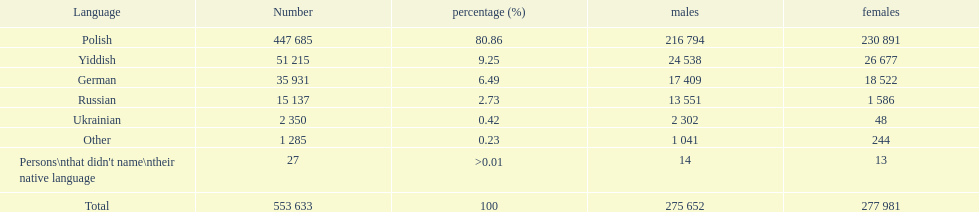What are the proportions of individuals? 80.86, 9.25, 6.49, 2.73, 0.42, 0.23, >0.01. Which language accounts for 0.42%? Ukrainian. 